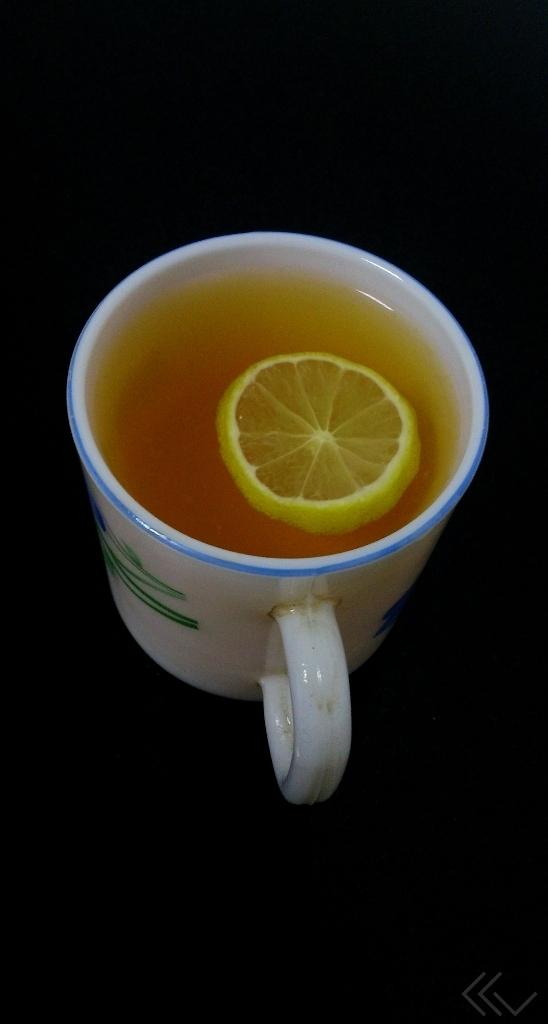What object is present on the table in the image? There is a cup on the table in the image. What is inside the cup? There is black tea and lemon in the cup. What type of branch can be seen growing out of the cup in the image? There is no branch growing out of the cup in the image; it contains black tea and lemon. 